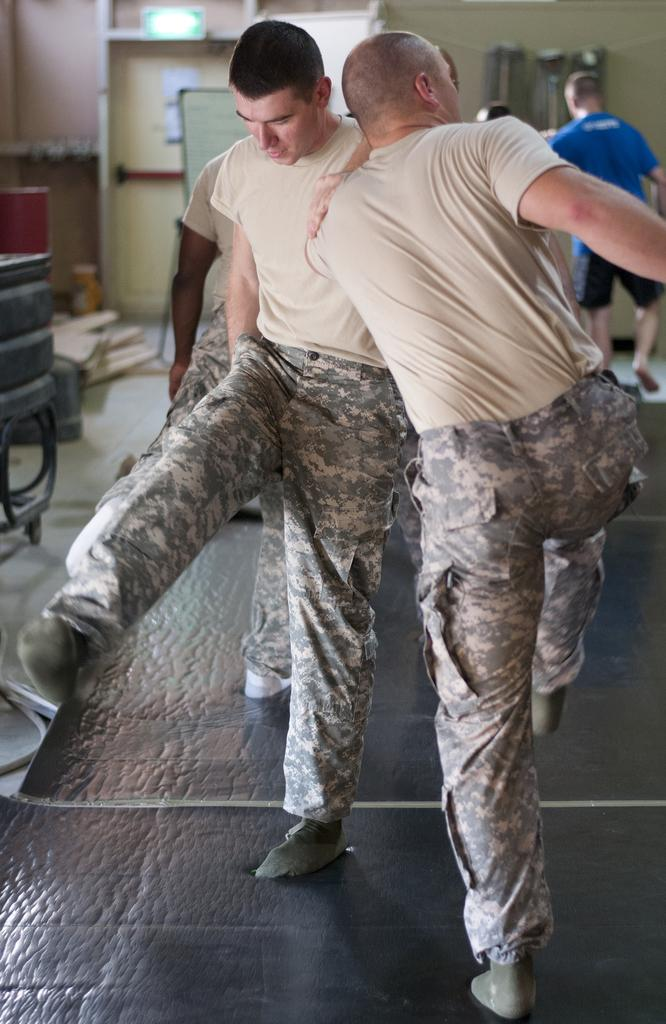What can be seen in the image? There are people standing in the image. Can you describe the clothing of the people? The people are wearing different color dresses. What is visible in the background of the image? There is a board and a wall in the background. What is on the floor in the image? There are objects on the floor in the image. What type of meat is being prepared on the edge of the board in the image? There is no meat or board present in the image. What type of rake is being used by the people in the image? There is no rake visible in the image. 